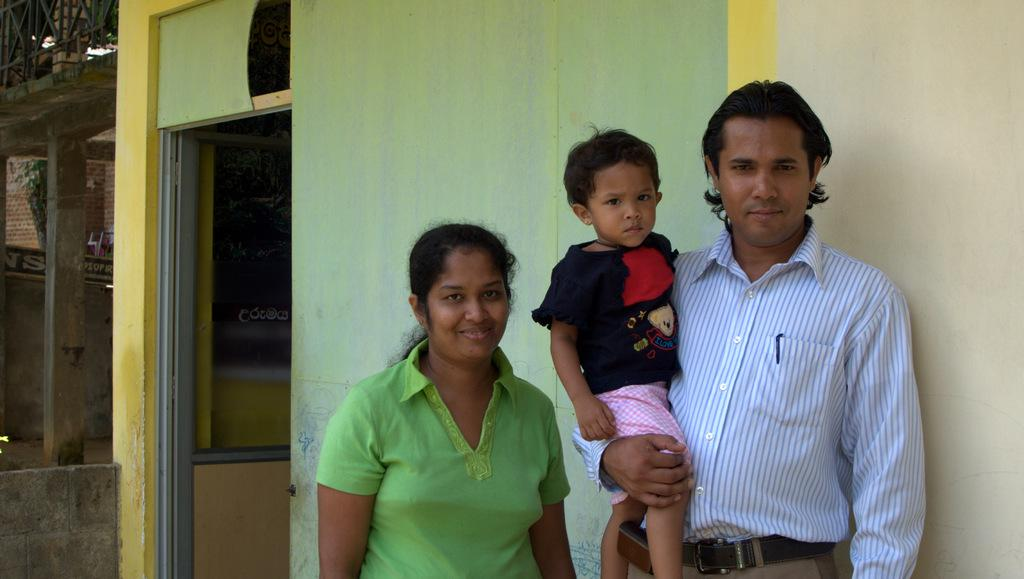How many people are in the image? There is a group of people in the image, but the exact number is not specified. What are the people doing in the image? The people are standing in front of a building. Can you describe the building in the image? The facts provided do not give any details about the building, so we cannot describe it. What book is being touched by the person in the image? There is no book present in the image, so no one can be touching a book. 